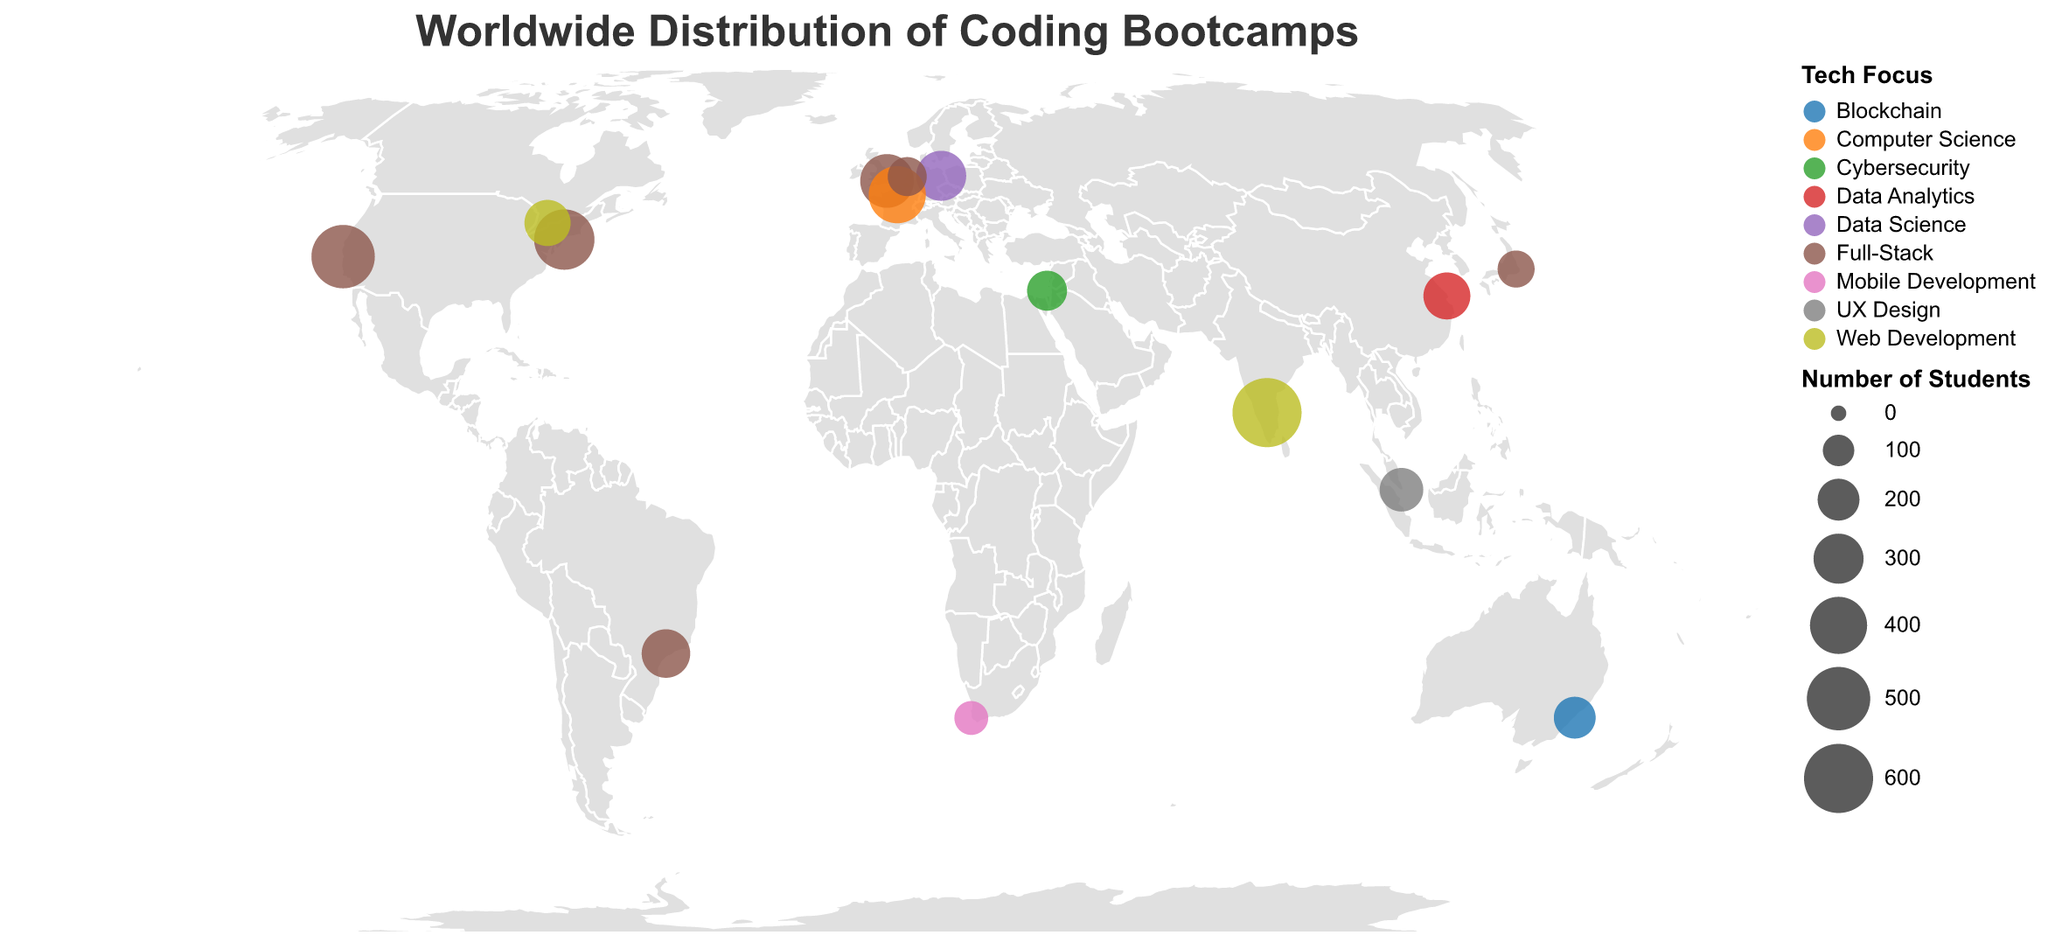What is the title of the figure? The title is located at the top of the figure and is the first textual element you see. It describes the overall content depicted in the plot.
Answer: Worldwide Distribution of Coding Bootcamps Which city has the highest number of students in a coding bootcamp? Observe the plotted circles on the map and their sizes, then refer to the tooltip information for each. The largest circle will have the highest number of students.
Answer: Bangalore What is the total number of students in Full-Stack bootcamps? Identify each bootcamp with a Full-Stack focus, then sum the student numbers for these bootcamps: San Francisco (500) + New York (450) + London (350) + Sao Paulo (280) + Tokyo (150) + Amsterdam (170).
Answer: 1900 Which country has the most diverse tech focuses in its bootcamps? Look at the color variations in each country. The country with the highest variety of colors has the most diverse tech focuses. Observe that the USA has Full-Stack (San Francisco and New York) and two different colors representing different focuses.
Answer: USA Compare the number of students in coding bootcamps between Europe and Asia. Which continent has more students? Sum the number of students in Europe (London: 350, Berlin: 300, Paris: 400, Amsterdam: 170) and compare it to Asia (Bangalore: 600, Tokyo: 150, Tel Aviv: 180, Singapore: 220, Shanghai: 260). Europe has 350 + 300 + 400 + 170 = 1220 and Asia has 600 + 150 + 180 + 220 + 260 = 1410.
Answer: Asia What is the tech focus of the coding bootcamp in Sydney? Look at the color corresponding to Sydney and refer to the legend to find the associated tech focus. According to the color, the tech focus is Blockchain.
Answer: Blockchain Which continent has the least number of students in coding bootcamps? Examine the number of student values (circle sizes) for each continent: Europe, Asia, North America, South America, Australia, and Africa. Compare the summed student counts for each. Africa has only 120 students from Cape Town.
Answer: Africa Compare the number of students in Web Development bootcamps between Bangalore and Toronto. Which city has more students? Sum each city's number of students where the tech focus is Web Development. Bangalore has 600 students, and Toronto has 250.
Answer: Bangalore What is the average number of students in coding bootcamps per city for the USA? The USA has two cities: San Francisco (500 students) and New York (450 students). Add these values and divide by 2: (500 + 450) / 2 = 475.
Answer: 475 What is the tech focus of the coding bootcamp with the least number of students? Look for the smallest circle on the map and refer to the tooltip information for its tech focus. The smallest circle represents Cape Town with 120 students focusing on Mobile Development.
Answer: Mobile Development 